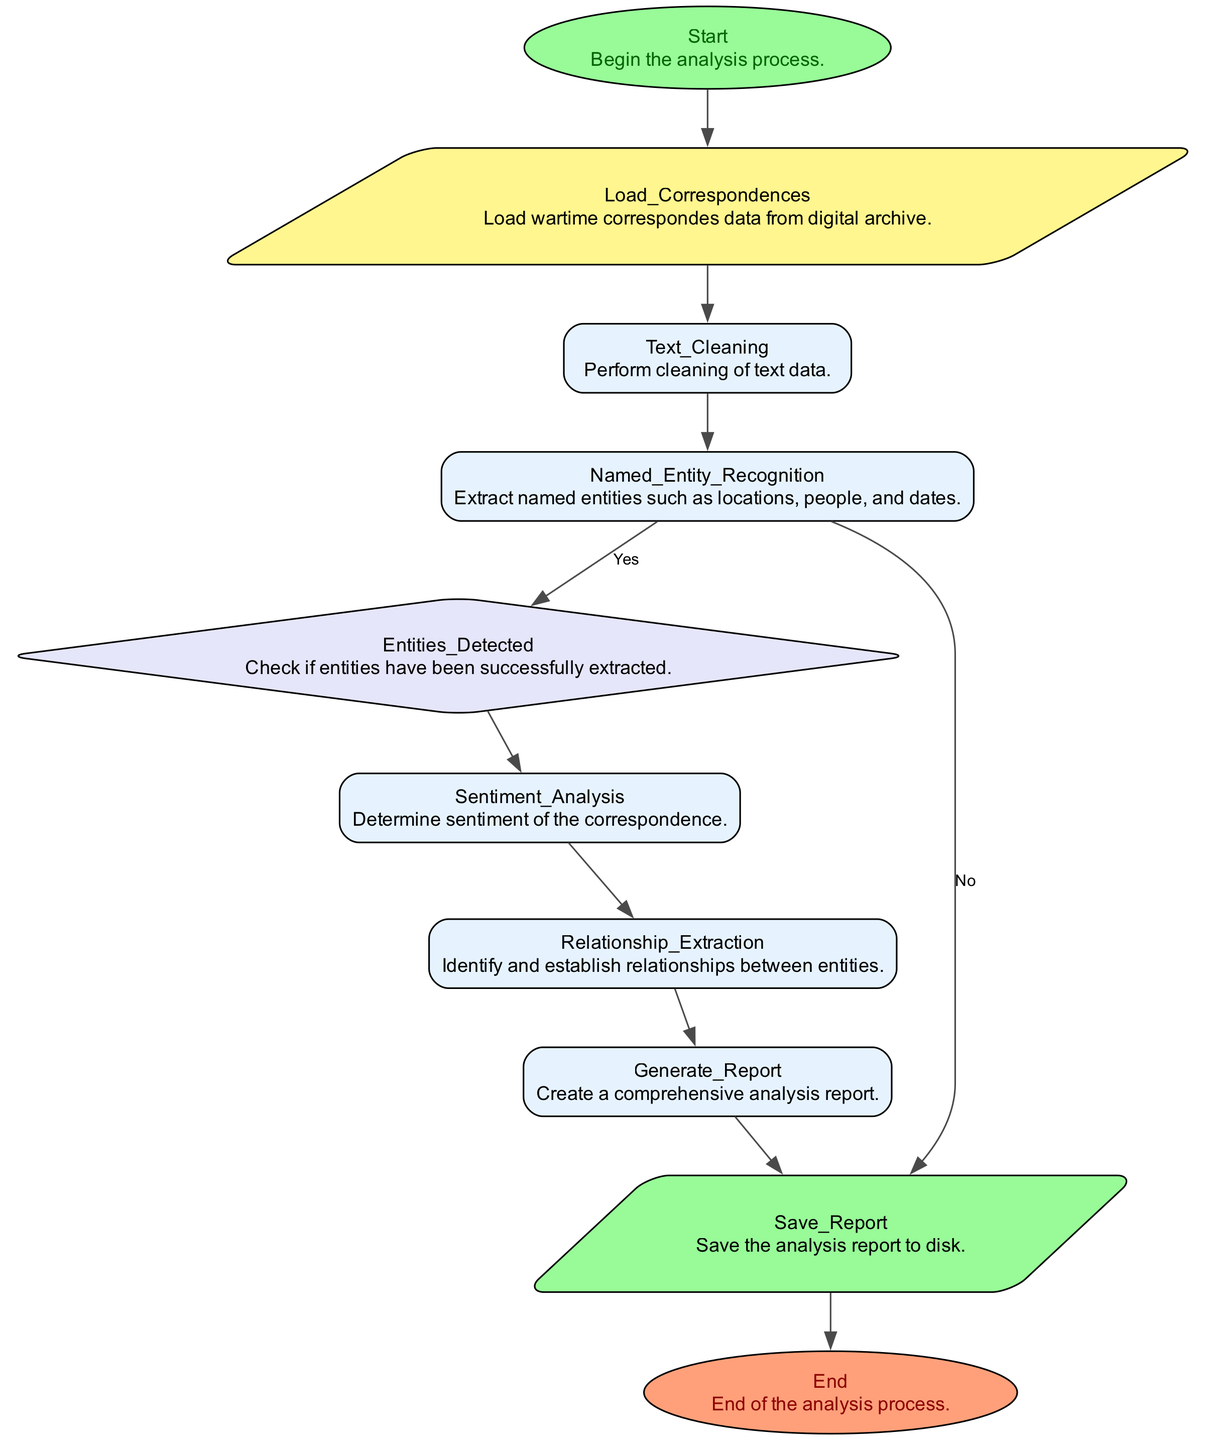What is the starting point of the analysis process? The starting point, also referred to as the "Start," is explicitly labeled in the diagram, indicating where the analysis begins.
Answer: Start How many main processes are present in the diagram? By counting the nodes labeled as "process," there are four main processes: Text Cleaning, Sentiment Analysis, Relationship Extraction, and Generate Report.
Answer: Four What is the final step of the analysis? The final step in the flowchart is indicated as "End," showing where the analysis process concludes.
Answer: End What is the first action taken after loading data? After loading the data from wartime correspondences, the next action taken is "Text Cleaning." This action involves preparing the text for further analysis.
Answer: Text Cleaning What happens if entities are not detected? If entities are not detected as per the decision point in the flowchart, the process would divert to a point that requires handling this lack of detection. However, the specific next step isn't detailed in the provided data; it's implied that the analysis would not proceed as expected.
Answer: Handle failure How many outputs are identified in the diagram? The flowchart indicates one output, which is "Save Report," specifying that the analysis report will be saved to disk after generation.
Answer: One Which node describes the relationship between identified entities? The node that describes the relationship between identified entities is "Relationship Extraction," where the relationships between named entities within the data are established.
Answer: Relationship Extraction What library is suggested for named entity recognition? The diagram mentions that libraries such as SpaCy or NLTK should be utilized for the task of named entity recognition in the wartime correspondences.
Answer: SpaCy or NLTK How is sentiment determined in the analysis? Sentiment is determined through a process labeled "Sentiment Analysis," where the text sentiment is classified into categories: positive, neutral, or negative, using machine learning techniques.
Answer: Sentiment Analysis 